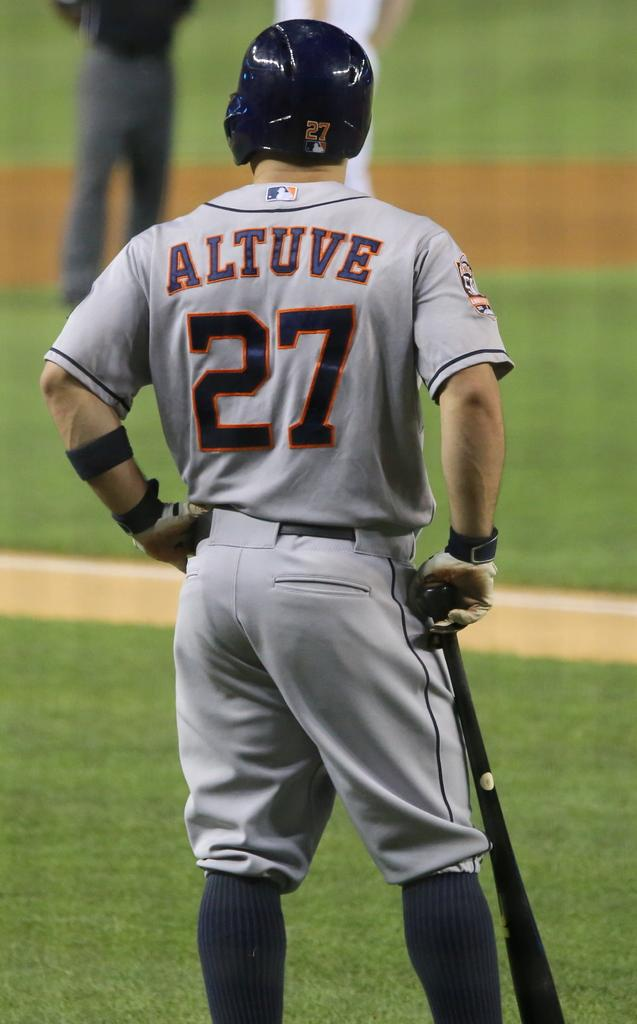<image>
Create a compact narrative representing the image presented. Player Altuve who wears number 27 is next up to bat. 